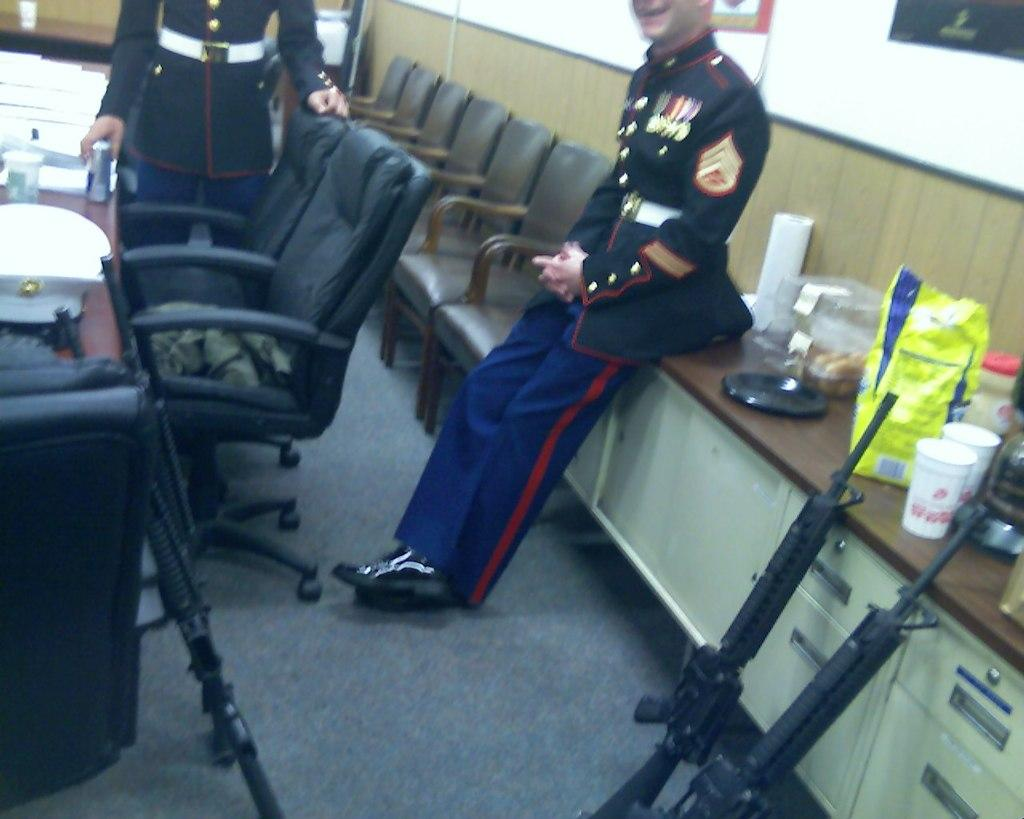How many people are in the image? There are two persons standing in the image. What type of furniture is visible in the image? Chairs and tables are present in the image. What objects are on the table? There is a hat, glasses, a plate, boxes, and food packs on the table. Are there any weapons visible in the image? Yes, guns are beside the table. What type of bomb is present in the image? There is no bomb present in the image. What crime is being committed in the image? There is no crime being committed in the image. 